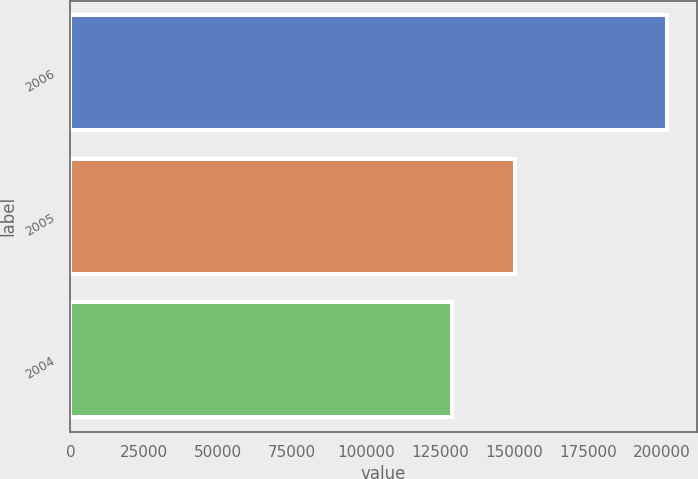Convert chart. <chart><loc_0><loc_0><loc_500><loc_500><bar_chart><fcel>2006<fcel>2005<fcel>2004<nl><fcel>201700<fcel>150410<fcel>129200<nl></chart> 